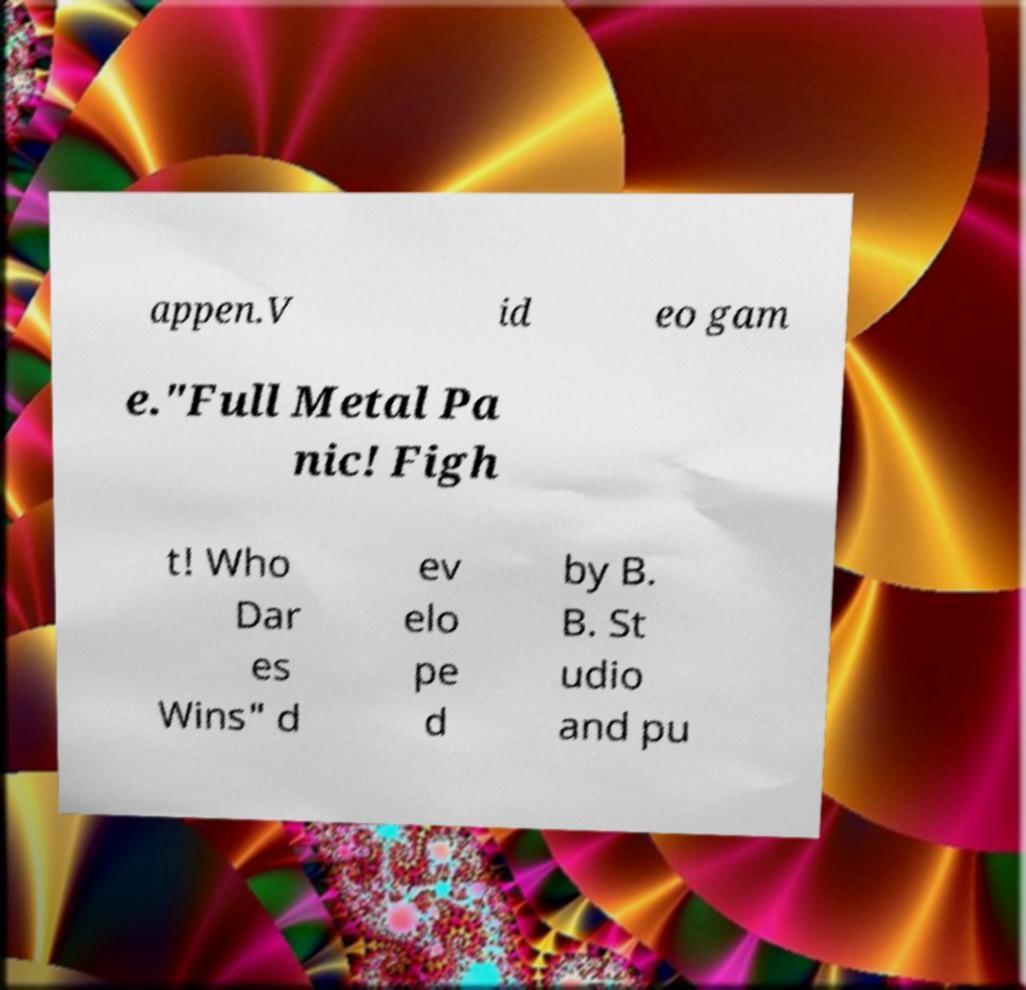Could you extract and type out the text from this image? appen.V id eo gam e."Full Metal Pa nic! Figh t! Who Dar es Wins" d ev elo pe d by B. B. St udio and pu 